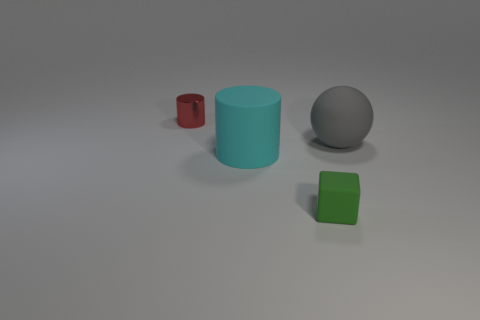There is a ball behind the small block; what color is it? The ball situated behind the small block appears to be gray, making it blend somewhat with the background, yet it's distinct enough to be noticeable. 